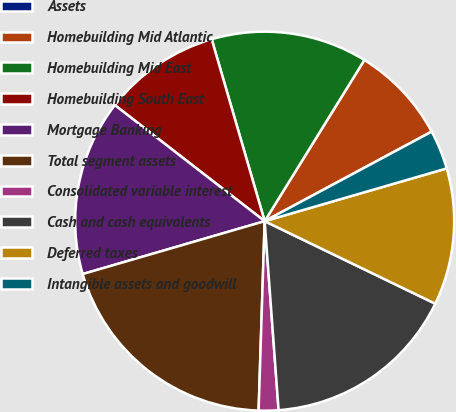<chart> <loc_0><loc_0><loc_500><loc_500><pie_chart><fcel>Assets<fcel>Homebuilding Mid Atlantic<fcel>Homebuilding Mid East<fcel>Homebuilding South East<fcel>Mortgage Banking<fcel>Total segment assets<fcel>Consolidated variable interest<fcel>Cash and cash equivalents<fcel>Deferred taxes<fcel>Intangible assets and goodwill<nl><fcel>0.01%<fcel>8.34%<fcel>13.33%<fcel>10.0%<fcel>14.99%<fcel>19.99%<fcel>1.68%<fcel>16.66%<fcel>11.66%<fcel>3.34%<nl></chart> 